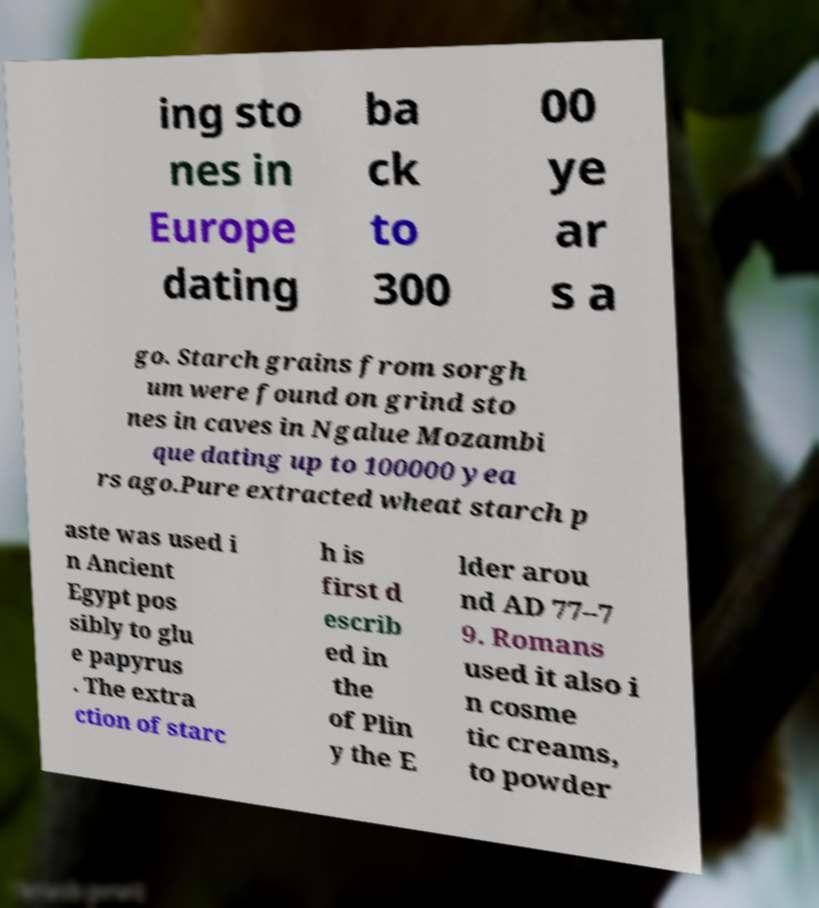There's text embedded in this image that I need extracted. Can you transcribe it verbatim? ing sto nes in Europe dating ba ck to 300 00 ye ar s a go. Starch grains from sorgh um were found on grind sto nes in caves in Ngalue Mozambi que dating up to 100000 yea rs ago.Pure extracted wheat starch p aste was used i n Ancient Egypt pos sibly to glu e papyrus . The extra ction of starc h is first d escrib ed in the of Plin y the E lder arou nd AD 77–7 9. Romans used it also i n cosme tic creams, to powder 